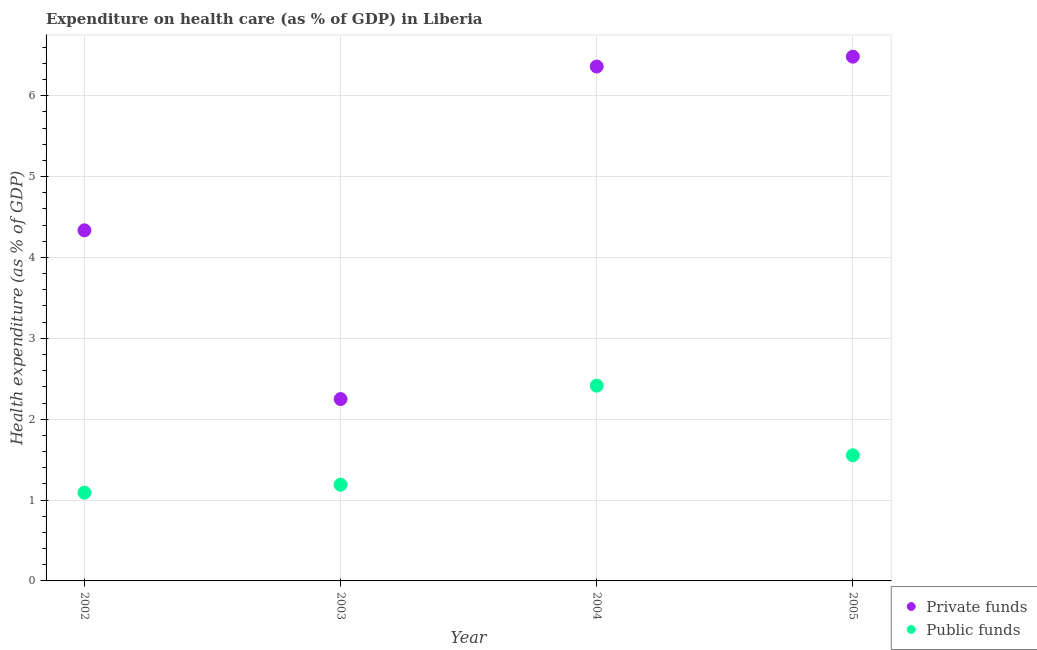How many different coloured dotlines are there?
Offer a very short reply. 2. What is the amount of private funds spent in healthcare in 2002?
Ensure brevity in your answer.  4.34. Across all years, what is the maximum amount of public funds spent in healthcare?
Provide a succinct answer. 2.41. Across all years, what is the minimum amount of private funds spent in healthcare?
Provide a succinct answer. 2.25. In which year was the amount of public funds spent in healthcare maximum?
Provide a succinct answer. 2004. In which year was the amount of public funds spent in healthcare minimum?
Your answer should be very brief. 2002. What is the total amount of private funds spent in healthcare in the graph?
Your answer should be compact. 19.43. What is the difference between the amount of public funds spent in healthcare in 2002 and that in 2004?
Make the answer very short. -1.32. What is the difference between the amount of private funds spent in healthcare in 2002 and the amount of public funds spent in healthcare in 2005?
Offer a terse response. 2.78. What is the average amount of public funds spent in healthcare per year?
Make the answer very short. 1.56. In the year 2002, what is the difference between the amount of public funds spent in healthcare and amount of private funds spent in healthcare?
Offer a terse response. -3.24. What is the ratio of the amount of public funds spent in healthcare in 2003 to that in 2004?
Keep it short and to the point. 0.49. Is the amount of public funds spent in healthcare in 2003 less than that in 2005?
Offer a very short reply. Yes. Is the difference between the amount of public funds spent in healthcare in 2003 and 2004 greater than the difference between the amount of private funds spent in healthcare in 2003 and 2004?
Make the answer very short. Yes. What is the difference between the highest and the second highest amount of private funds spent in healthcare?
Your response must be concise. 0.12. What is the difference between the highest and the lowest amount of public funds spent in healthcare?
Provide a succinct answer. 1.32. Does the amount of private funds spent in healthcare monotonically increase over the years?
Your response must be concise. No. Is the amount of private funds spent in healthcare strictly greater than the amount of public funds spent in healthcare over the years?
Give a very brief answer. Yes. Is the amount of private funds spent in healthcare strictly less than the amount of public funds spent in healthcare over the years?
Your answer should be compact. No. How many dotlines are there?
Keep it short and to the point. 2. How many years are there in the graph?
Your response must be concise. 4. Are the values on the major ticks of Y-axis written in scientific E-notation?
Make the answer very short. No. How many legend labels are there?
Offer a terse response. 2. What is the title of the graph?
Make the answer very short. Expenditure on health care (as % of GDP) in Liberia. Does "Electricity" appear as one of the legend labels in the graph?
Provide a short and direct response. No. What is the label or title of the X-axis?
Give a very brief answer. Year. What is the label or title of the Y-axis?
Your answer should be compact. Health expenditure (as % of GDP). What is the Health expenditure (as % of GDP) in Private funds in 2002?
Provide a succinct answer. 4.34. What is the Health expenditure (as % of GDP) of Public funds in 2002?
Provide a short and direct response. 1.09. What is the Health expenditure (as % of GDP) in Private funds in 2003?
Your answer should be very brief. 2.25. What is the Health expenditure (as % of GDP) in Public funds in 2003?
Provide a short and direct response. 1.19. What is the Health expenditure (as % of GDP) in Private funds in 2004?
Provide a short and direct response. 6.36. What is the Health expenditure (as % of GDP) in Public funds in 2004?
Your answer should be compact. 2.41. What is the Health expenditure (as % of GDP) in Private funds in 2005?
Offer a very short reply. 6.48. What is the Health expenditure (as % of GDP) in Public funds in 2005?
Give a very brief answer. 1.55. Across all years, what is the maximum Health expenditure (as % of GDP) in Private funds?
Ensure brevity in your answer.  6.48. Across all years, what is the maximum Health expenditure (as % of GDP) of Public funds?
Keep it short and to the point. 2.41. Across all years, what is the minimum Health expenditure (as % of GDP) in Private funds?
Your answer should be very brief. 2.25. Across all years, what is the minimum Health expenditure (as % of GDP) in Public funds?
Keep it short and to the point. 1.09. What is the total Health expenditure (as % of GDP) in Private funds in the graph?
Provide a succinct answer. 19.43. What is the total Health expenditure (as % of GDP) of Public funds in the graph?
Your answer should be very brief. 6.25. What is the difference between the Health expenditure (as % of GDP) of Private funds in 2002 and that in 2003?
Provide a short and direct response. 2.09. What is the difference between the Health expenditure (as % of GDP) of Public funds in 2002 and that in 2003?
Give a very brief answer. -0.1. What is the difference between the Health expenditure (as % of GDP) of Private funds in 2002 and that in 2004?
Provide a short and direct response. -2.03. What is the difference between the Health expenditure (as % of GDP) in Public funds in 2002 and that in 2004?
Your answer should be compact. -1.32. What is the difference between the Health expenditure (as % of GDP) in Private funds in 2002 and that in 2005?
Make the answer very short. -2.15. What is the difference between the Health expenditure (as % of GDP) in Public funds in 2002 and that in 2005?
Offer a very short reply. -0.46. What is the difference between the Health expenditure (as % of GDP) of Private funds in 2003 and that in 2004?
Offer a very short reply. -4.11. What is the difference between the Health expenditure (as % of GDP) in Public funds in 2003 and that in 2004?
Offer a very short reply. -1.22. What is the difference between the Health expenditure (as % of GDP) in Private funds in 2003 and that in 2005?
Provide a succinct answer. -4.23. What is the difference between the Health expenditure (as % of GDP) in Public funds in 2003 and that in 2005?
Provide a short and direct response. -0.36. What is the difference between the Health expenditure (as % of GDP) in Private funds in 2004 and that in 2005?
Ensure brevity in your answer.  -0.12. What is the difference between the Health expenditure (as % of GDP) in Public funds in 2004 and that in 2005?
Provide a short and direct response. 0.86. What is the difference between the Health expenditure (as % of GDP) in Private funds in 2002 and the Health expenditure (as % of GDP) in Public funds in 2003?
Give a very brief answer. 3.15. What is the difference between the Health expenditure (as % of GDP) of Private funds in 2002 and the Health expenditure (as % of GDP) of Public funds in 2004?
Provide a succinct answer. 1.92. What is the difference between the Health expenditure (as % of GDP) in Private funds in 2002 and the Health expenditure (as % of GDP) in Public funds in 2005?
Keep it short and to the point. 2.78. What is the difference between the Health expenditure (as % of GDP) in Private funds in 2003 and the Health expenditure (as % of GDP) in Public funds in 2004?
Offer a very short reply. -0.17. What is the difference between the Health expenditure (as % of GDP) in Private funds in 2003 and the Health expenditure (as % of GDP) in Public funds in 2005?
Offer a terse response. 0.7. What is the difference between the Health expenditure (as % of GDP) in Private funds in 2004 and the Health expenditure (as % of GDP) in Public funds in 2005?
Offer a terse response. 4.81. What is the average Health expenditure (as % of GDP) of Private funds per year?
Provide a succinct answer. 4.86. What is the average Health expenditure (as % of GDP) of Public funds per year?
Provide a short and direct response. 1.56. In the year 2002, what is the difference between the Health expenditure (as % of GDP) in Private funds and Health expenditure (as % of GDP) in Public funds?
Provide a short and direct response. 3.24. In the year 2003, what is the difference between the Health expenditure (as % of GDP) of Private funds and Health expenditure (as % of GDP) of Public funds?
Keep it short and to the point. 1.06. In the year 2004, what is the difference between the Health expenditure (as % of GDP) of Private funds and Health expenditure (as % of GDP) of Public funds?
Your response must be concise. 3.95. In the year 2005, what is the difference between the Health expenditure (as % of GDP) in Private funds and Health expenditure (as % of GDP) in Public funds?
Ensure brevity in your answer.  4.93. What is the ratio of the Health expenditure (as % of GDP) in Private funds in 2002 to that in 2003?
Offer a very short reply. 1.93. What is the ratio of the Health expenditure (as % of GDP) in Public funds in 2002 to that in 2003?
Offer a terse response. 0.92. What is the ratio of the Health expenditure (as % of GDP) of Private funds in 2002 to that in 2004?
Your response must be concise. 0.68. What is the ratio of the Health expenditure (as % of GDP) in Public funds in 2002 to that in 2004?
Offer a terse response. 0.45. What is the ratio of the Health expenditure (as % of GDP) in Private funds in 2002 to that in 2005?
Offer a terse response. 0.67. What is the ratio of the Health expenditure (as % of GDP) of Public funds in 2002 to that in 2005?
Your response must be concise. 0.7. What is the ratio of the Health expenditure (as % of GDP) in Private funds in 2003 to that in 2004?
Your answer should be compact. 0.35. What is the ratio of the Health expenditure (as % of GDP) of Public funds in 2003 to that in 2004?
Provide a short and direct response. 0.49. What is the ratio of the Health expenditure (as % of GDP) of Private funds in 2003 to that in 2005?
Your answer should be compact. 0.35. What is the ratio of the Health expenditure (as % of GDP) in Public funds in 2003 to that in 2005?
Your answer should be compact. 0.77. What is the ratio of the Health expenditure (as % of GDP) in Private funds in 2004 to that in 2005?
Make the answer very short. 0.98. What is the ratio of the Health expenditure (as % of GDP) in Public funds in 2004 to that in 2005?
Provide a short and direct response. 1.55. What is the difference between the highest and the second highest Health expenditure (as % of GDP) of Private funds?
Offer a very short reply. 0.12. What is the difference between the highest and the second highest Health expenditure (as % of GDP) in Public funds?
Provide a short and direct response. 0.86. What is the difference between the highest and the lowest Health expenditure (as % of GDP) in Private funds?
Give a very brief answer. 4.23. What is the difference between the highest and the lowest Health expenditure (as % of GDP) of Public funds?
Your response must be concise. 1.32. 